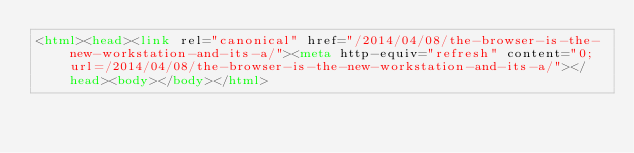Convert code to text. <code><loc_0><loc_0><loc_500><loc_500><_HTML_><html><head><link rel="canonical" href="/2014/04/08/the-browser-is-the-new-workstation-and-its-a/"><meta http-equiv="refresh" content="0; url=/2014/04/08/the-browser-is-the-new-workstation-and-its-a/"></head><body></body></html>
</code> 